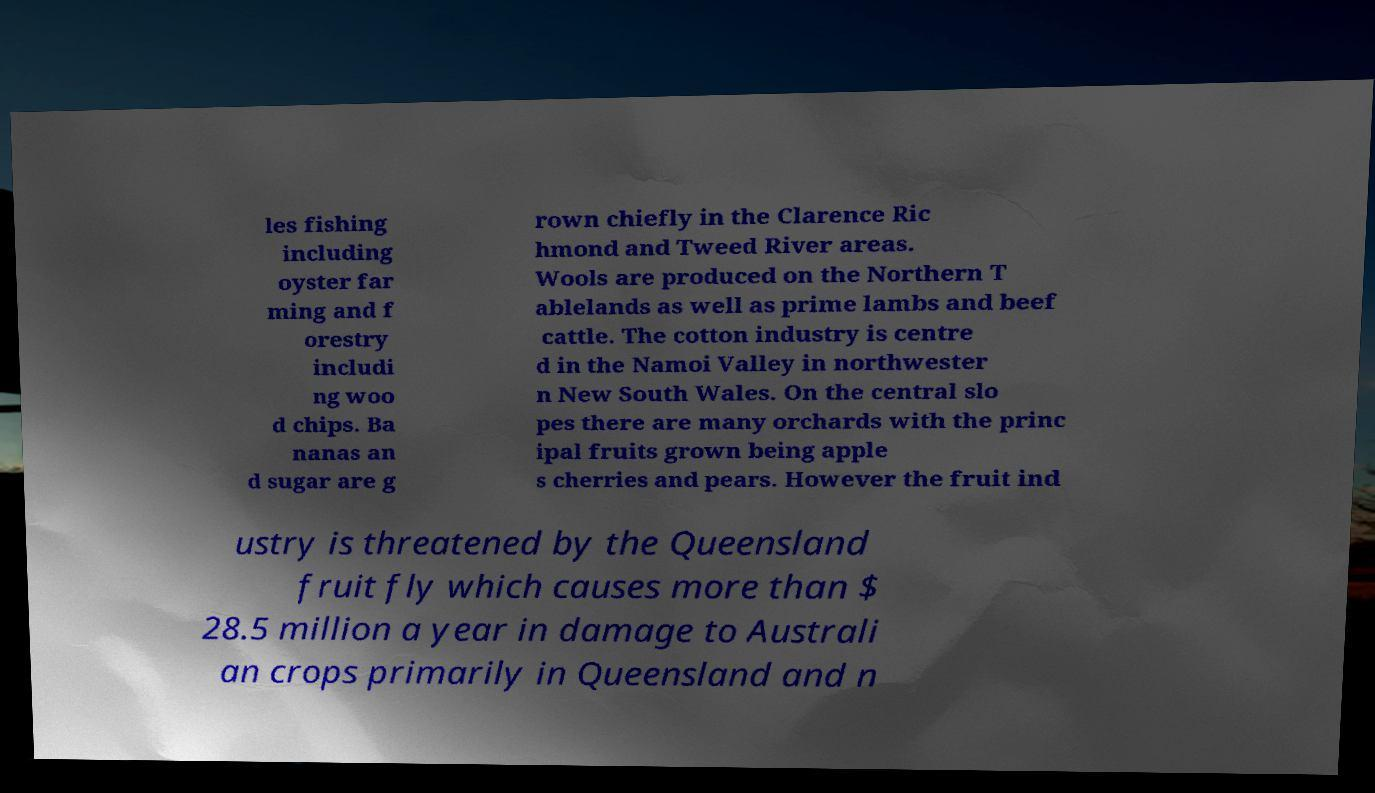Could you assist in decoding the text presented in this image and type it out clearly? les fishing including oyster far ming and f orestry includi ng woo d chips. Ba nanas an d sugar are g rown chiefly in the Clarence Ric hmond and Tweed River areas. Wools are produced on the Northern T ablelands as well as prime lambs and beef cattle. The cotton industry is centre d in the Namoi Valley in northwester n New South Wales. On the central slo pes there are many orchards with the princ ipal fruits grown being apple s cherries and pears. However the fruit ind ustry is threatened by the Queensland fruit fly which causes more than $ 28.5 million a year in damage to Australi an crops primarily in Queensland and n 